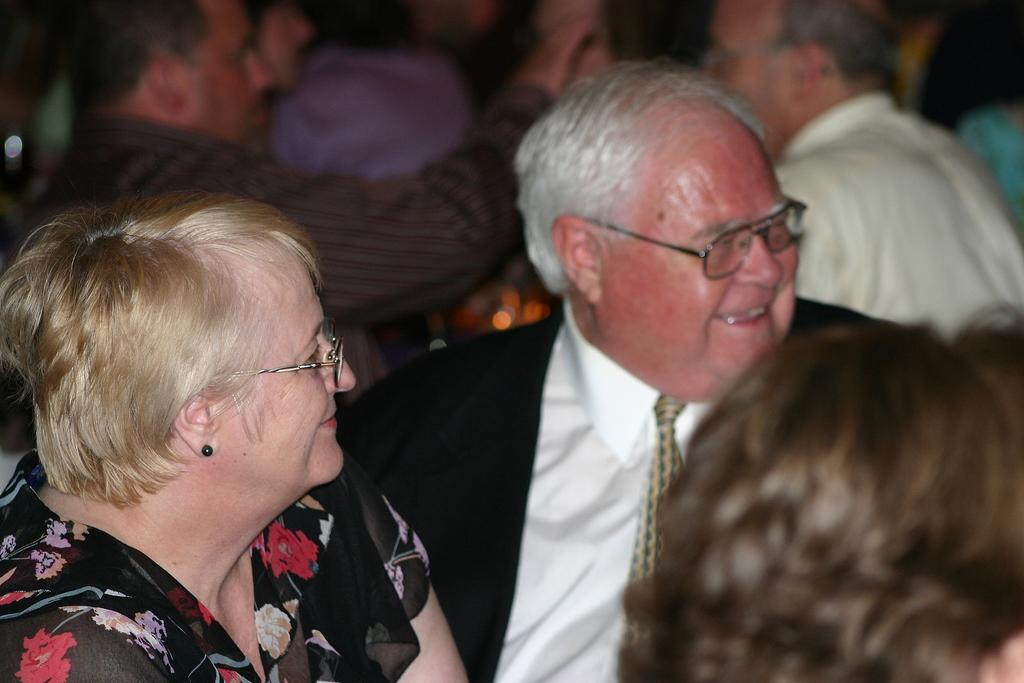How many people are in the image? There are persons in the image. What are the persons wearing? The persons are wearing clothes. Can you describe any specific accessories worn by the persons? Two of the persons are wearing spectacles. What type of crown is worn by the person in the image? There is no crown present in the image. Can you tell me if the persons in the image are in a hospital? The image does not provide any information about the location or setting, so it cannot be determined if the persons are in a hospital. 